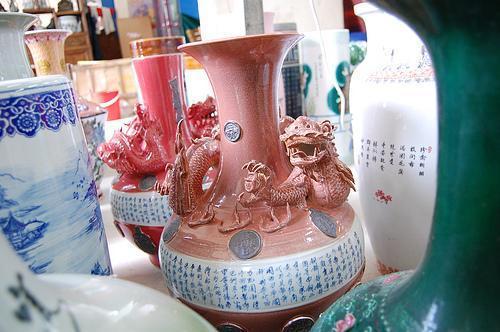How many blue vases are there in the image?
Give a very brief answer. 1. How many red vases are in the image?
Give a very brief answer. 1. 